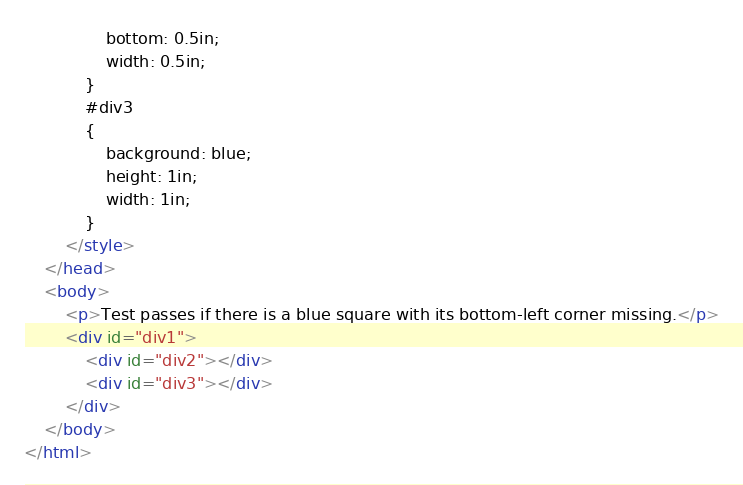<code> <loc_0><loc_0><loc_500><loc_500><_HTML_>                bottom: 0.5in;
                width: 0.5in;
            }
            #div3
            {
                background: blue;
                height: 1in;
                width: 1in;
            }
        </style>
    </head>
    <body>
        <p>Test passes if there is a blue square with its bottom-left corner missing.</p>
        <div id="div1">
            <div id="div2"></div>
            <div id="div3"></div>
        </div>
    </body>
</html></code> 